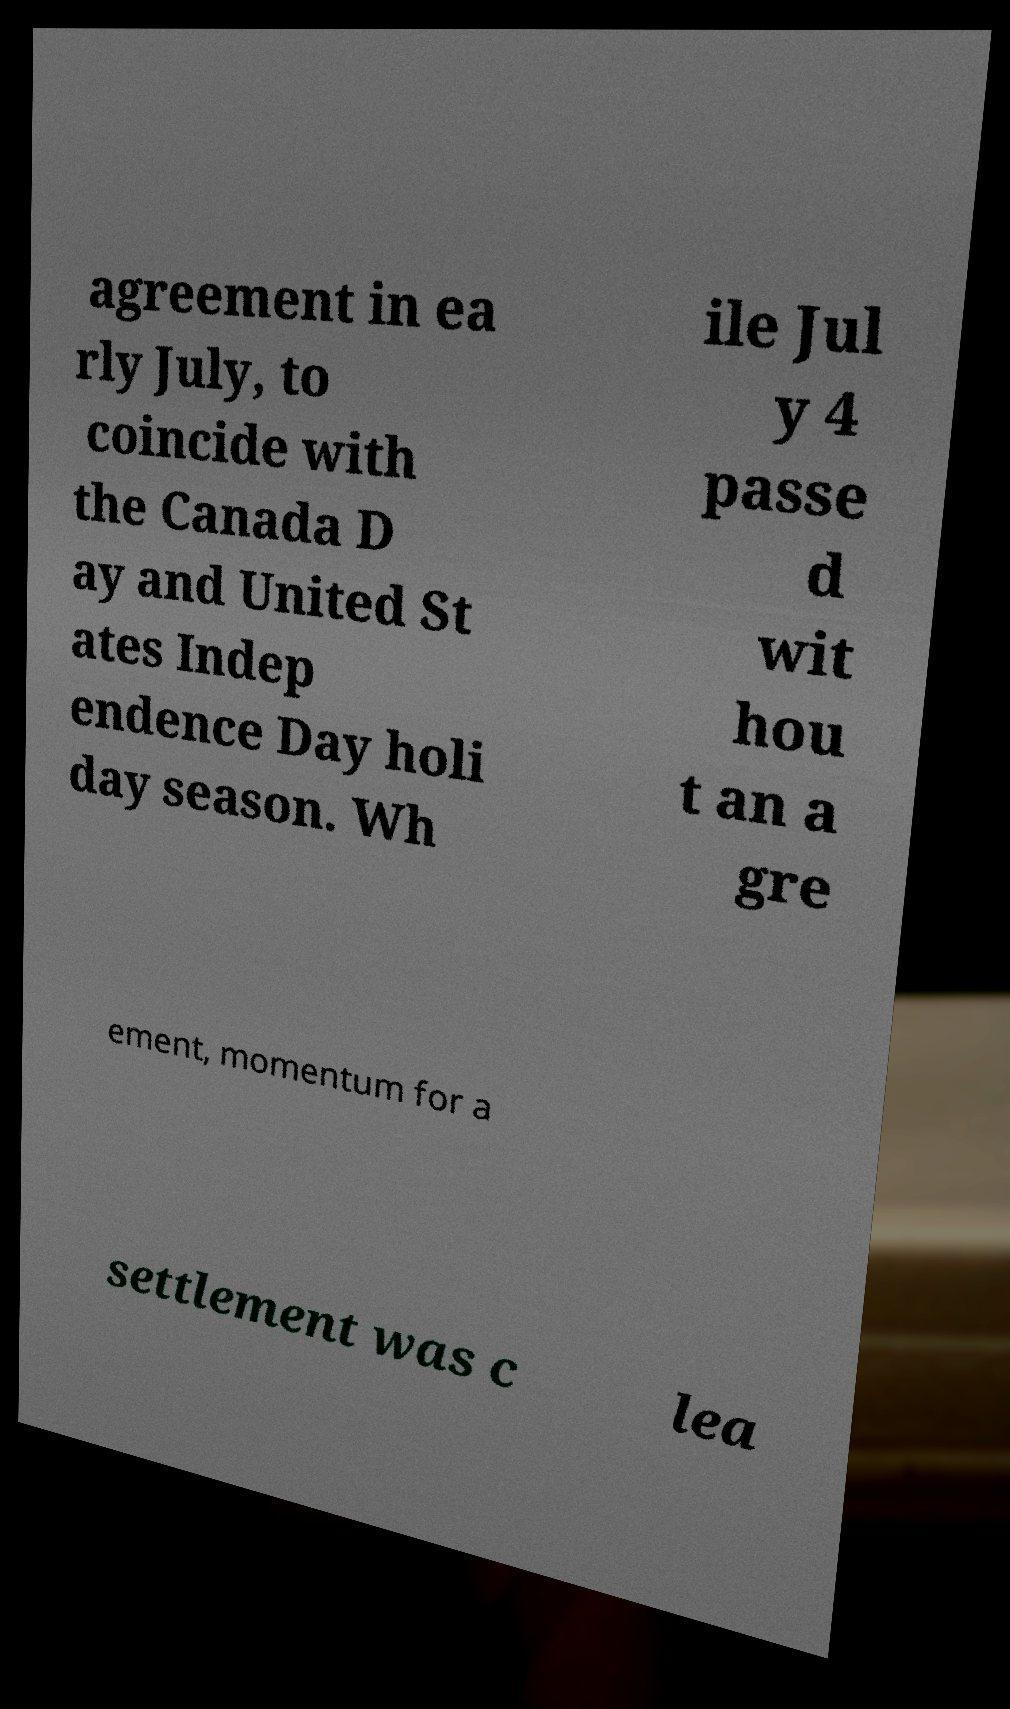There's text embedded in this image that I need extracted. Can you transcribe it verbatim? agreement in ea rly July, to coincide with the Canada D ay and United St ates Indep endence Day holi day season. Wh ile Jul y 4 passe d wit hou t an a gre ement, momentum for a settlement was c lea 